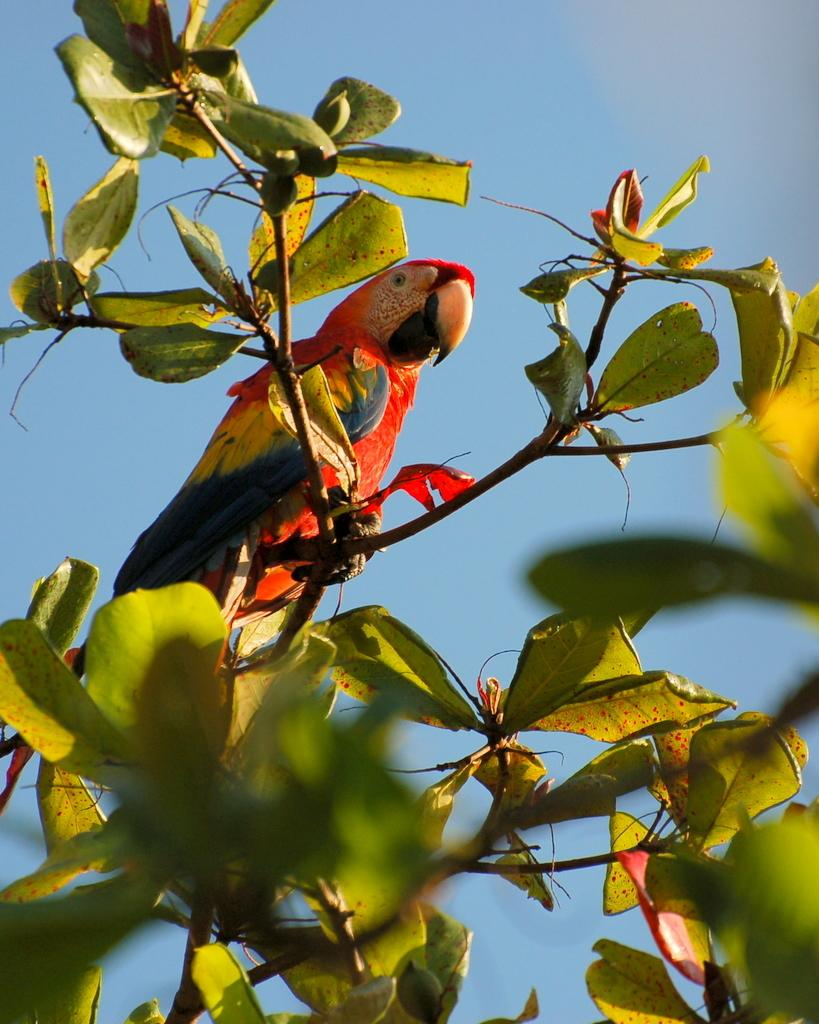What is present in the image besides the tree? There is a bird in the image. Where is the bird located in relation to the tree? The bird is sitting on a branch of the tree. What caption is written on the image? There is no caption present in the image. How many dogs can be seen in the image? There are no dogs present in the image. 